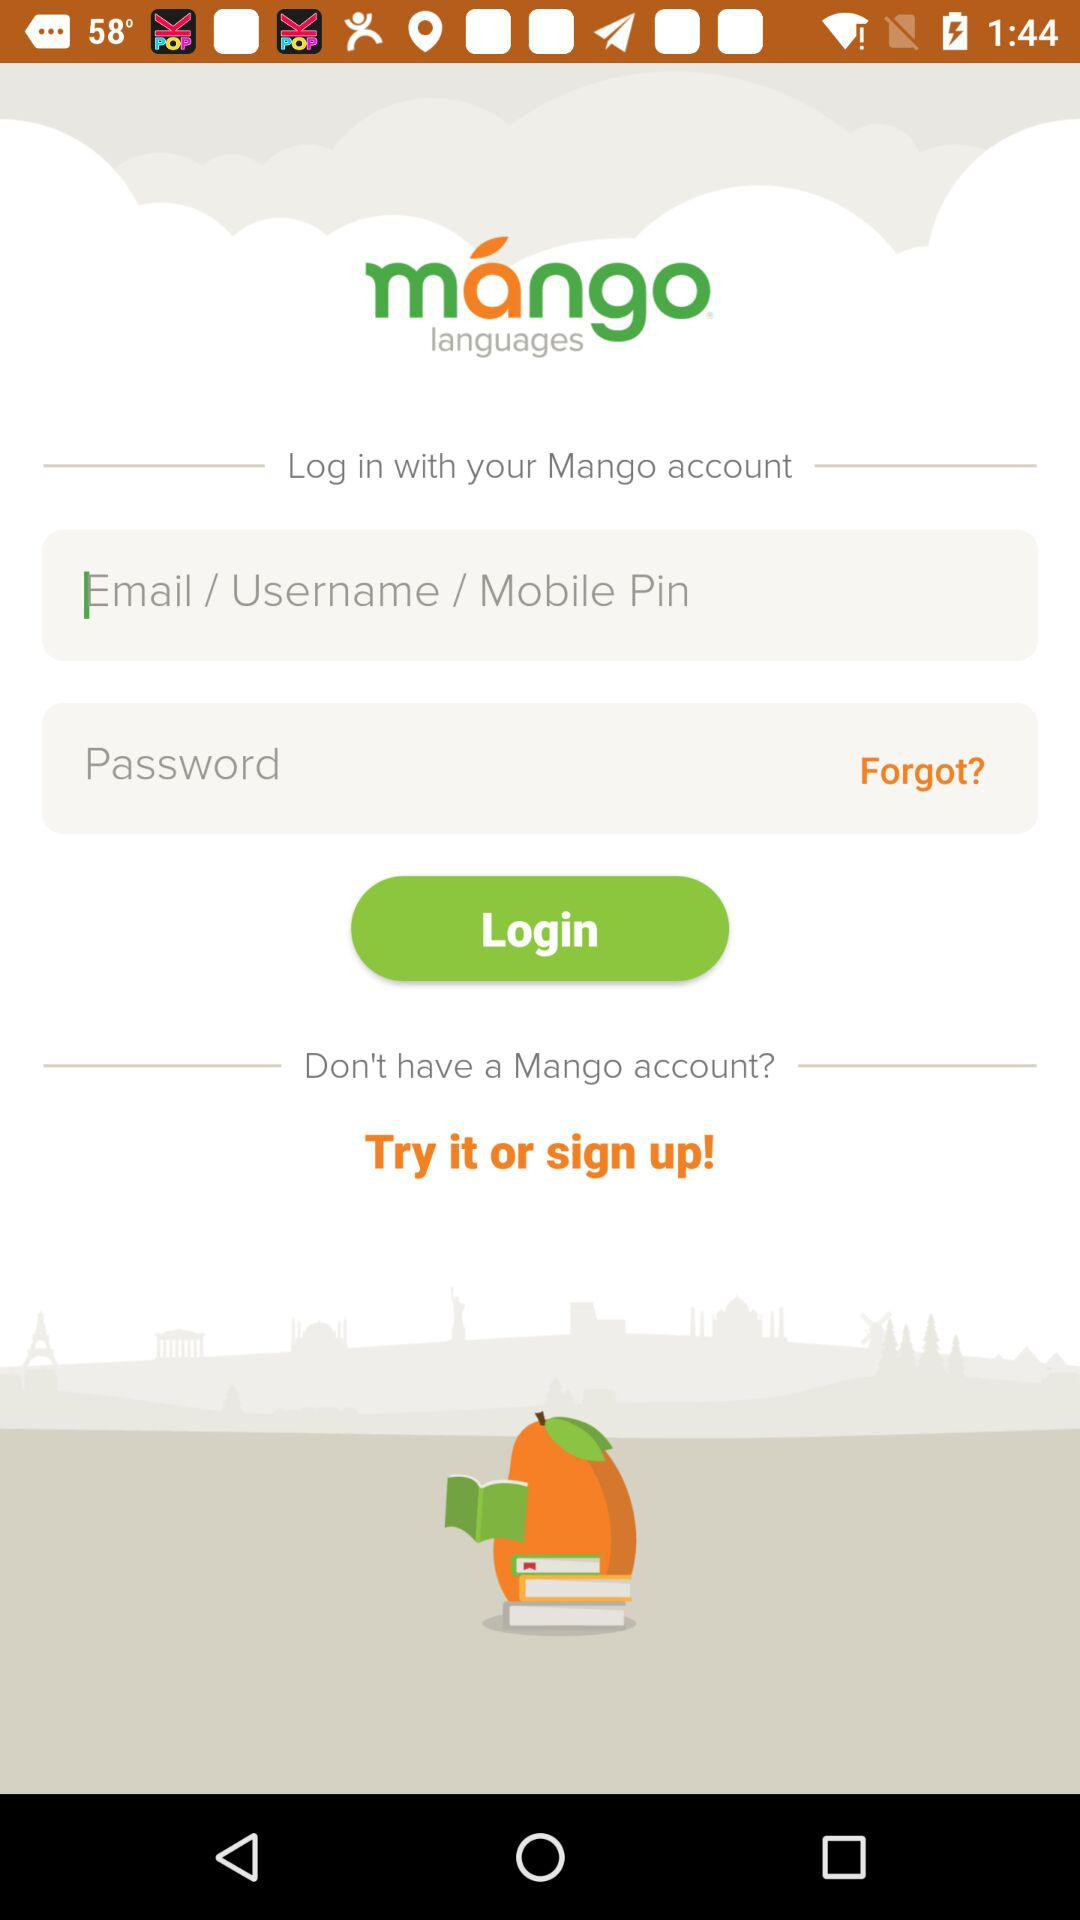What is the app name? The app name is "mángo languages". 